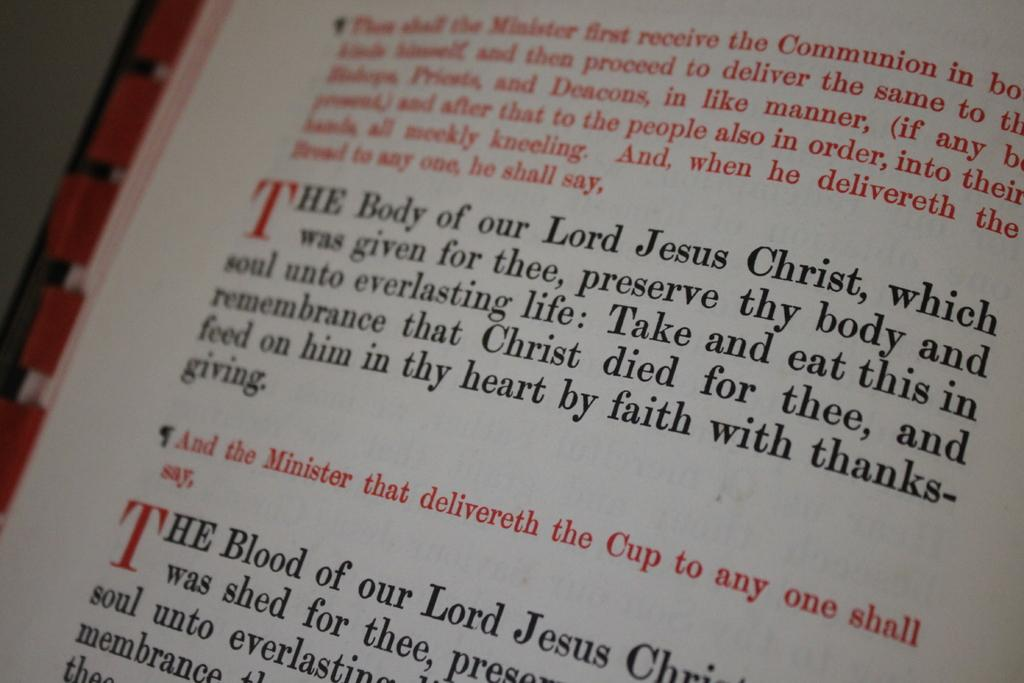Provide a one-sentence caption for the provided image. Passage from the Bible with every first letter T capitalized and red. 